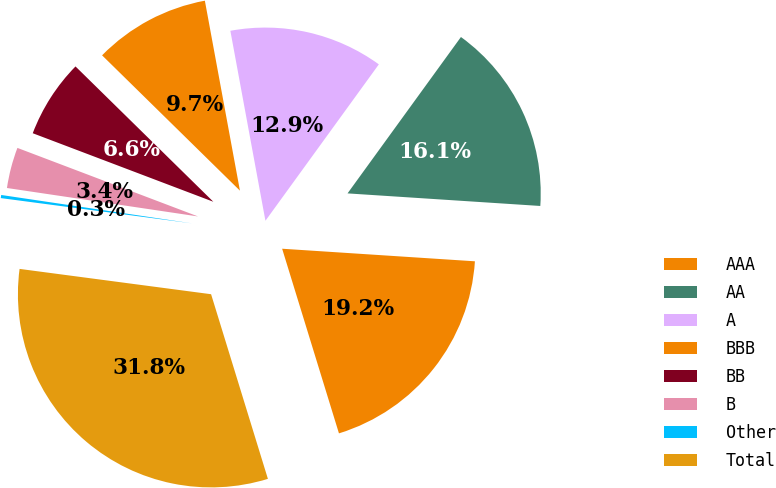Convert chart. <chart><loc_0><loc_0><loc_500><loc_500><pie_chart><fcel>AAA<fcel>AA<fcel>A<fcel>BBB<fcel>BB<fcel>B<fcel>Other<fcel>Total<nl><fcel>19.21%<fcel>16.05%<fcel>12.89%<fcel>9.74%<fcel>6.58%<fcel>3.42%<fcel>0.26%<fcel>31.84%<nl></chart> 